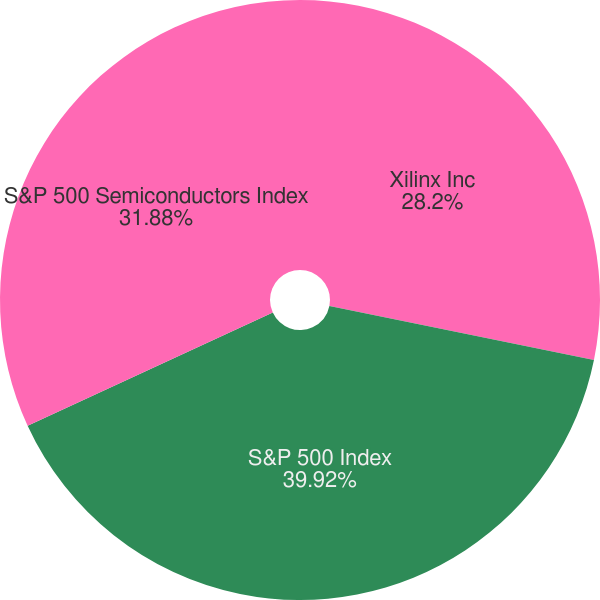<chart> <loc_0><loc_0><loc_500><loc_500><pie_chart><fcel>Xilinx Inc<fcel>S&P 500 Index<fcel>S&P 500 Semiconductors Index<nl><fcel>28.2%<fcel>39.91%<fcel>31.88%<nl></chart> 